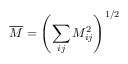Convert formula to latex. <formula><loc_0><loc_0><loc_500><loc_500>\overline { M } = \left ( \sum _ { i j } M _ { i j } ^ { 2 } \right ) ^ { 1 / 2 }</formula> 